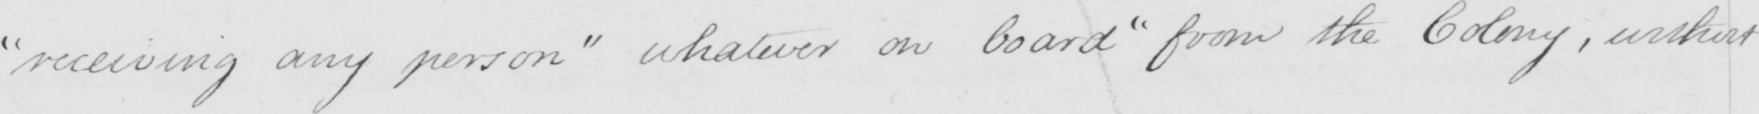What is written in this line of handwriting? " receiving any person "  whatever on board  " from the Colony , without 